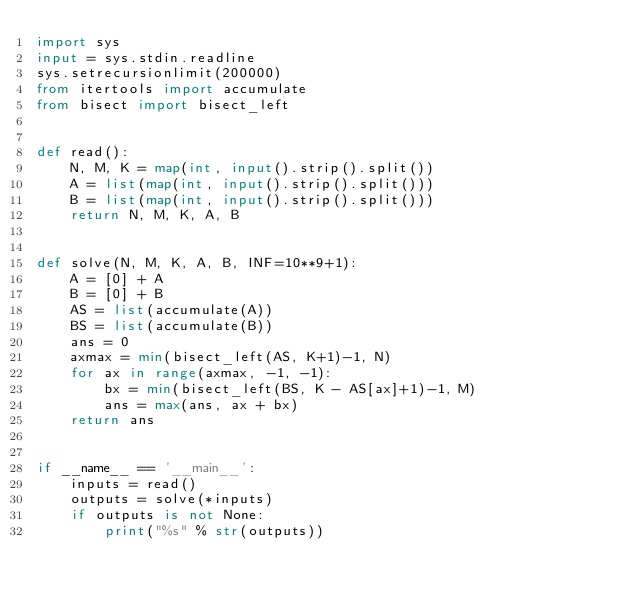<code> <loc_0><loc_0><loc_500><loc_500><_Python_>import sys
input = sys.stdin.readline
sys.setrecursionlimit(200000)
from itertools import accumulate
from bisect import bisect_left


def read():
    N, M, K = map(int, input().strip().split())
    A = list(map(int, input().strip().split()))
    B = list(map(int, input().strip().split()))
    return N, M, K, A, B


def solve(N, M, K, A, B, INF=10**9+1):
    A = [0] + A
    B = [0] + B
    AS = list(accumulate(A))
    BS = list(accumulate(B))
    ans = 0
    axmax = min(bisect_left(AS, K+1)-1, N)
    for ax in range(axmax, -1, -1):
        bx = min(bisect_left(BS, K - AS[ax]+1)-1, M)
        ans = max(ans, ax + bx)
    return ans


if __name__ == '__main__':
    inputs = read()
    outputs = solve(*inputs)
    if outputs is not None:
        print("%s" % str(outputs))
</code> 